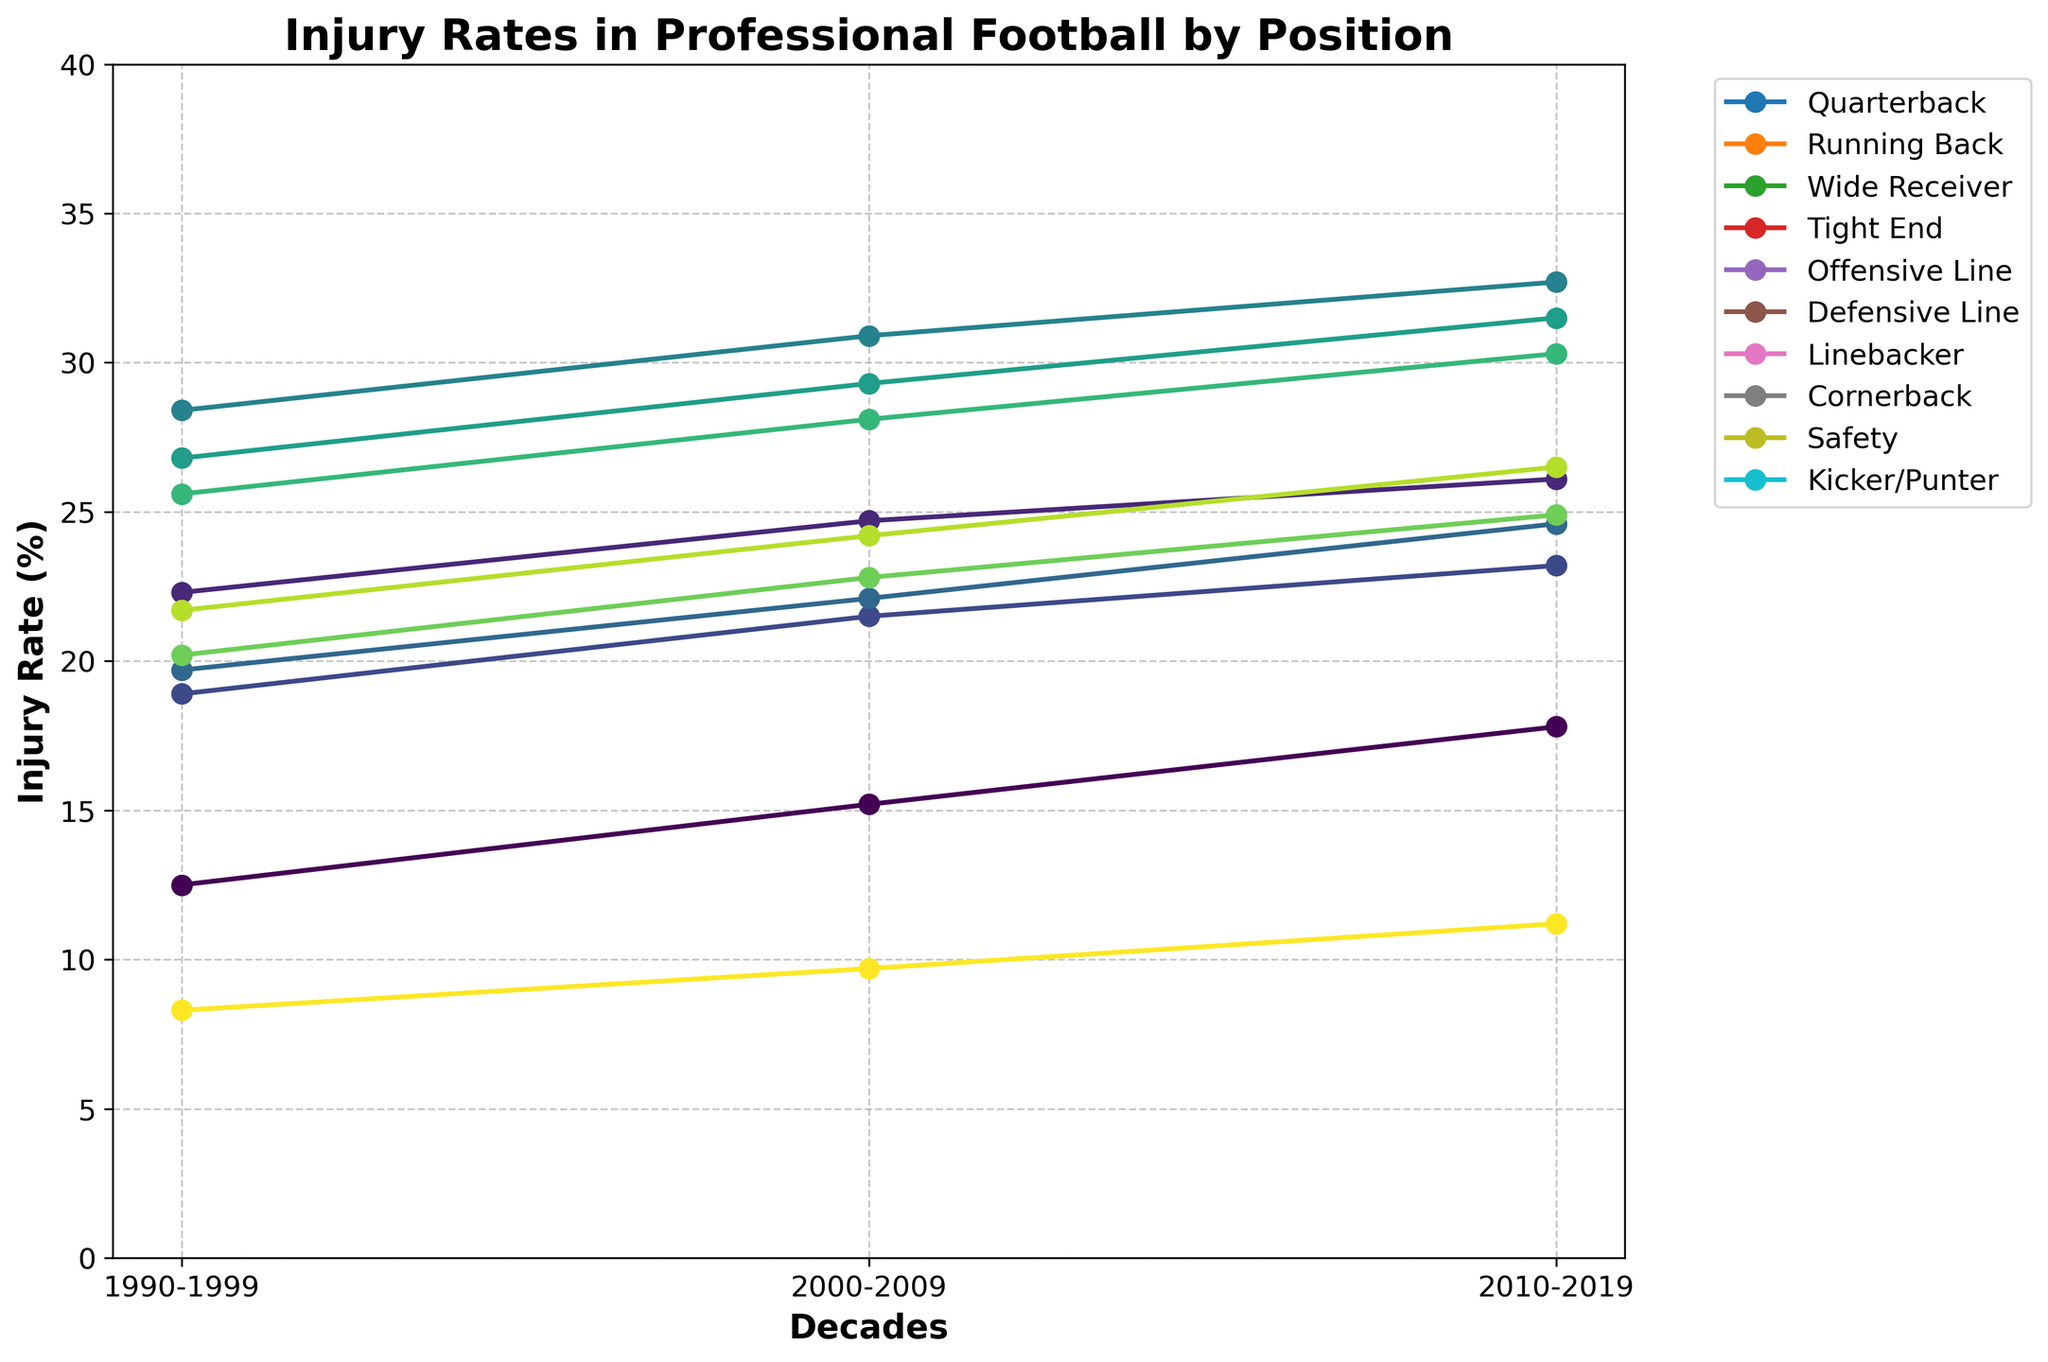Which position had the highest injury rate in 2010-2019? The visual chart shows lines for each position over the decades. In 2010-2019, the position with the highest data point is the Offensive Line.
Answer: Offensive Line Which decade saw the largest increase in injury rates for Tight Ends? Observing the line for Tight Ends across the three decades, the increase from 2000-2009 to 2010-2019 is 2.5 (24.6 - 22.1) and the increase from 1990-1999 to 2000-2009 is 2.4 (22.1 - 19.7). The largest increase is from 2000-2009 to 2010-2019.
Answer: 2000-2009 to 2010-2019 Between the decades 1990-1999 and 2010-2019, which position had a smaller increase in injury rates: Wide Receiver or Quarterback? From the chart, the increase for Wide Receiver is 4.3 (23.2 - 18.9) and for Quarterback is 5.3 (17.8 - 12.5). Therefore, Wide Receiver had a smaller increase.
Answer: Wide Receiver Which position showed the smallest change in injury rates between any two consecutive decades? Analyzing the chart shows that Kicker/Punter has the smallest change between 2000-2009 and 2010-2019, with an increase of 1.5 (11.2 - 9.7).
Answer: Kicker/Punter What is the average injury rate for Linebackers across all three decades? Looking at the chart, the injury rates for Linebackers are 25.6, 28.1, and 30.3. The average is calculated as (25.6 + 28.1 + 30.3) / 3 = 28.0.
Answer: 28.0 By how many percentage points did injury rates for Cornerbacks increase from 1990-1999 to 2010-2019? The injury rates for Cornerbacks in 1990-1999 and 2010-2019 are 20.2 and 24.9, respectively. The increase is 24.9 - 20.2 = 4.7 percentage points.
Answer: 4.7 During which decade did Quarterbacks and Running Backs have the closest injury rates? Comparing the differences in each decade: 1990-1999 (22.3 - 12.5 = 9.8), 2000-2009 (24.7 - 15.2 = 9.5), 2010-2019 (26.1 - 17.8 = 8.3). The closest difference is during 2010-2019.
Answer: 2010-2019 How much did the injury rate for Safety change from the first to the last decade? The injury rate for Safety in 1990-1999 is 21.7 and in 2010-2019 is 26.5. The change is 26.5 - 21.7 = 4.8.
Answer: 4.8 Which position consistently had the lowest injury rate over the three decades? Observing the chart, the Kicker/Punter line consistently shows the lowest injury rates across all three decades.
Answer: Kicker/Punter 